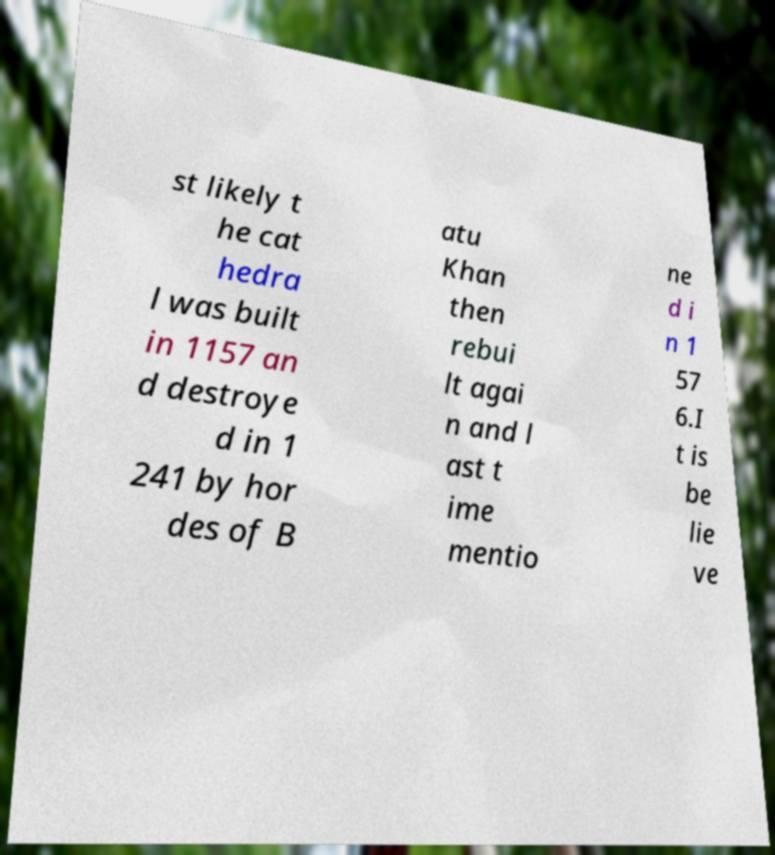Can you read and provide the text displayed in the image?This photo seems to have some interesting text. Can you extract and type it out for me? st likely t he cat hedra l was built in 1157 an d destroye d in 1 241 by hor des of B atu Khan then rebui lt agai n and l ast t ime mentio ne d i n 1 57 6.I t is be lie ve 